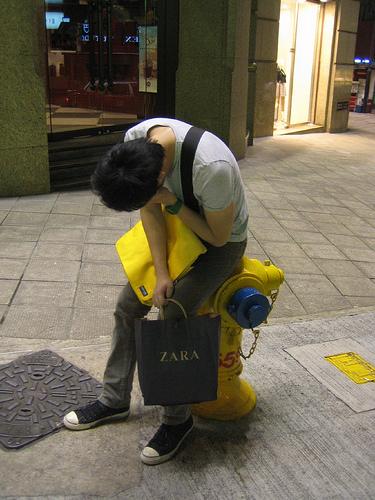Is the person crying?
Keep it brief. Yes. What is the man sitting on?
Concise answer only. Fire hydrant. What color is the person's shoes?
Give a very brief answer. Black. 